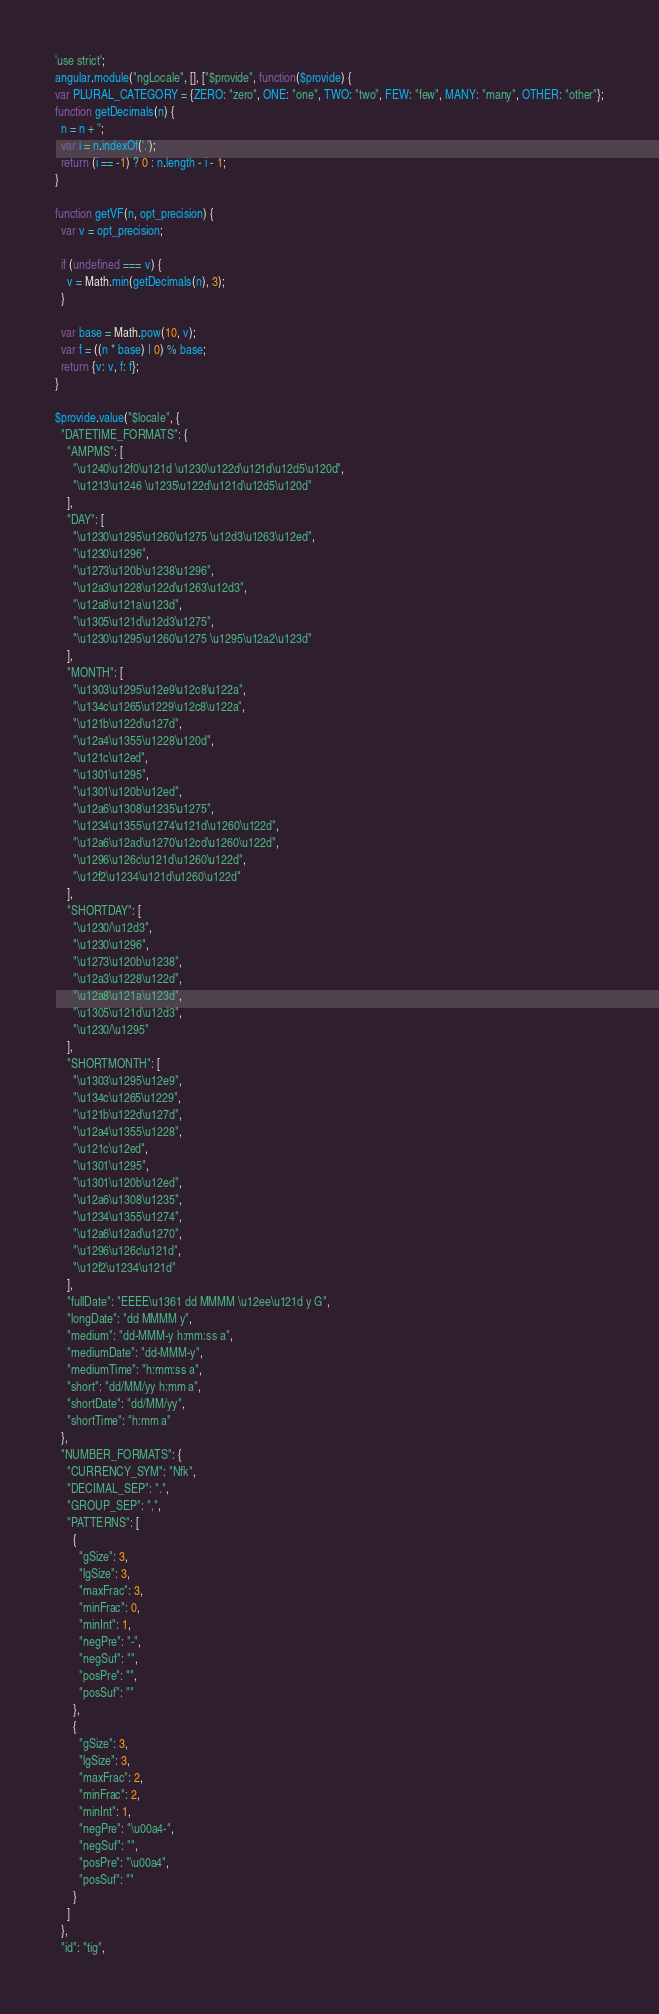<code> <loc_0><loc_0><loc_500><loc_500><_JavaScript_>'use strict';
angular.module("ngLocale", [], ["$provide", function($provide) {
var PLURAL_CATEGORY = {ZERO: "zero", ONE: "one", TWO: "two", FEW: "few", MANY: "many", OTHER: "other"};
function getDecimals(n) {
  n = n + '';
  var i = n.indexOf('.');
  return (i == -1) ? 0 : n.length - i - 1;
}

function getVF(n, opt_precision) {
  var v = opt_precision;

  if (undefined === v) {
    v = Math.min(getDecimals(n), 3);
  }

  var base = Math.pow(10, v);
  var f = ((n * base) | 0) % base;
  return {v: v, f: f};
}

$provide.value("$locale", {
  "DATETIME_FORMATS": {
    "AMPMS": [
      "\u1240\u12f0\u121d \u1230\u122d\u121d\u12d5\u120d",
      "\u1213\u1246 \u1235\u122d\u121d\u12d5\u120d"
    ],
    "DAY": [
      "\u1230\u1295\u1260\u1275 \u12d3\u1263\u12ed",
      "\u1230\u1296",
      "\u1273\u120b\u1238\u1296",
      "\u12a3\u1228\u122d\u1263\u12d3",
      "\u12a8\u121a\u123d",
      "\u1305\u121d\u12d3\u1275",
      "\u1230\u1295\u1260\u1275 \u1295\u12a2\u123d"
    ],
    "MONTH": [
      "\u1303\u1295\u12e9\u12c8\u122a",
      "\u134c\u1265\u1229\u12c8\u122a",
      "\u121b\u122d\u127d",
      "\u12a4\u1355\u1228\u120d",
      "\u121c\u12ed",
      "\u1301\u1295",
      "\u1301\u120b\u12ed",
      "\u12a6\u1308\u1235\u1275",
      "\u1234\u1355\u1274\u121d\u1260\u122d",
      "\u12a6\u12ad\u1270\u12cd\u1260\u122d",
      "\u1296\u126c\u121d\u1260\u122d",
      "\u12f2\u1234\u121d\u1260\u122d"
    ],
    "SHORTDAY": [
      "\u1230/\u12d3",
      "\u1230\u1296",
      "\u1273\u120b\u1238",
      "\u12a3\u1228\u122d",
      "\u12a8\u121a\u123d",
      "\u1305\u121d\u12d3",
      "\u1230/\u1295"
    ],
    "SHORTMONTH": [
      "\u1303\u1295\u12e9",
      "\u134c\u1265\u1229",
      "\u121b\u122d\u127d",
      "\u12a4\u1355\u1228",
      "\u121c\u12ed",
      "\u1301\u1295",
      "\u1301\u120b\u12ed",
      "\u12a6\u1308\u1235",
      "\u1234\u1355\u1274",
      "\u12a6\u12ad\u1270",
      "\u1296\u126c\u121d",
      "\u12f2\u1234\u121d"
    ],
    "fullDate": "EEEE\u1361 dd MMMM \u12ee\u121d y G",
    "longDate": "dd MMMM y",
    "medium": "dd-MMM-y h:mm:ss a",
    "mediumDate": "dd-MMM-y",
    "mediumTime": "h:mm:ss a",
    "short": "dd/MM/yy h:mm a",
    "shortDate": "dd/MM/yy",
    "shortTime": "h:mm a"
  },
  "NUMBER_FORMATS": {
    "CURRENCY_SYM": "Nfk",
    "DECIMAL_SEP": ".",
    "GROUP_SEP": ",",
    "PATTERNS": [
      {
        "gSize": 3,
        "lgSize": 3,
        "maxFrac": 3,
        "minFrac": 0,
        "minInt": 1,
        "negPre": "-",
        "negSuf": "",
        "posPre": "",
        "posSuf": ""
      },
      {
        "gSize": 3,
        "lgSize": 3,
        "maxFrac": 2,
        "minFrac": 2,
        "minInt": 1,
        "negPre": "\u00a4-",
        "negSuf": "",
        "posPre": "\u00a4",
        "posSuf": ""
      }
    ]
  },
  "id": "tig",</code> 